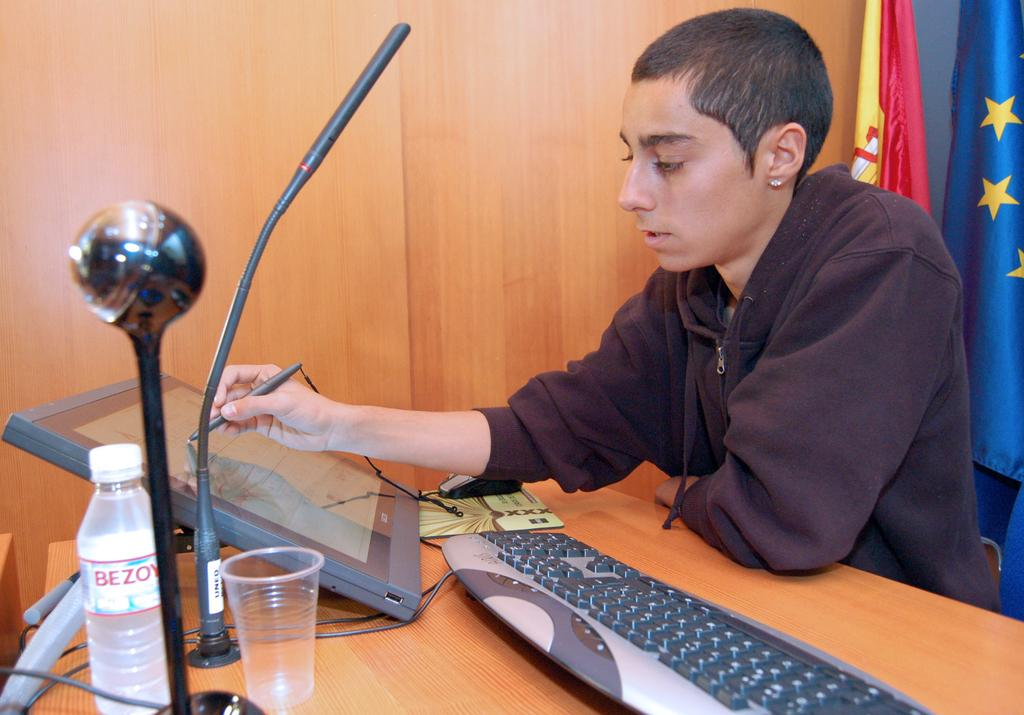<image>
Write a terse but informative summary of the picture. A guy sits at a desk with a Bezoy brand bottle of water. 